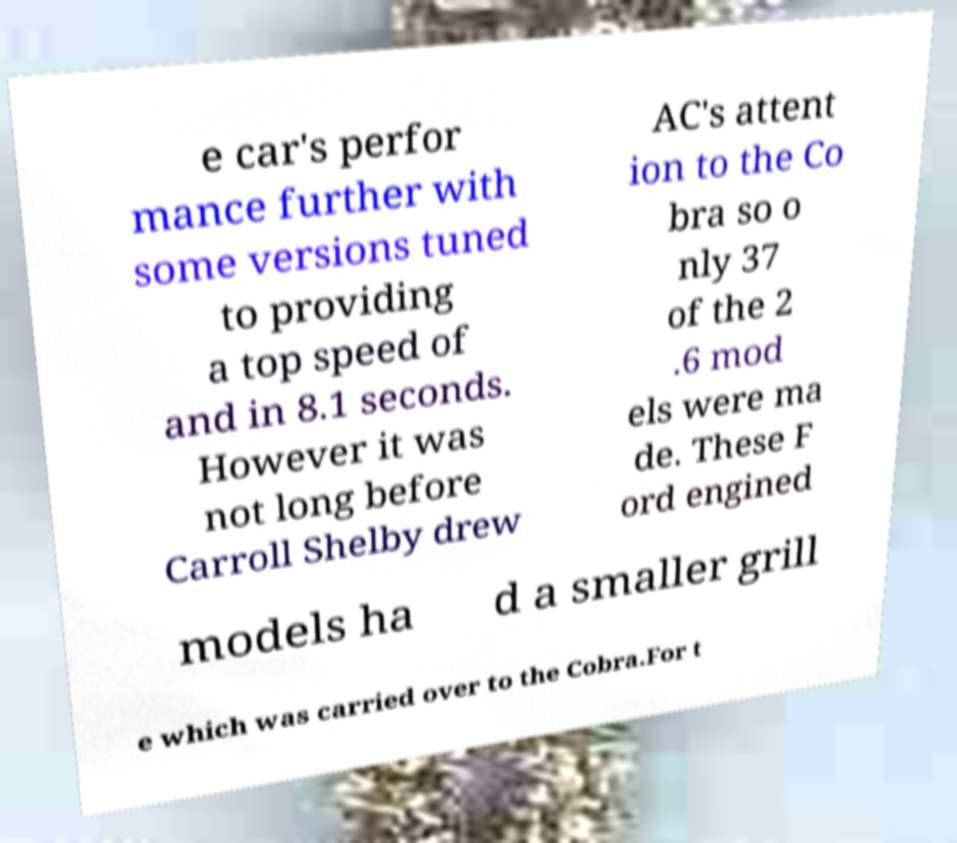Could you assist in decoding the text presented in this image and type it out clearly? e car's perfor mance further with some versions tuned to providing a top speed of and in 8.1 seconds. However it was not long before Carroll Shelby drew AC's attent ion to the Co bra so o nly 37 of the 2 .6 mod els were ma de. These F ord engined models ha d a smaller grill e which was carried over to the Cobra.For t 